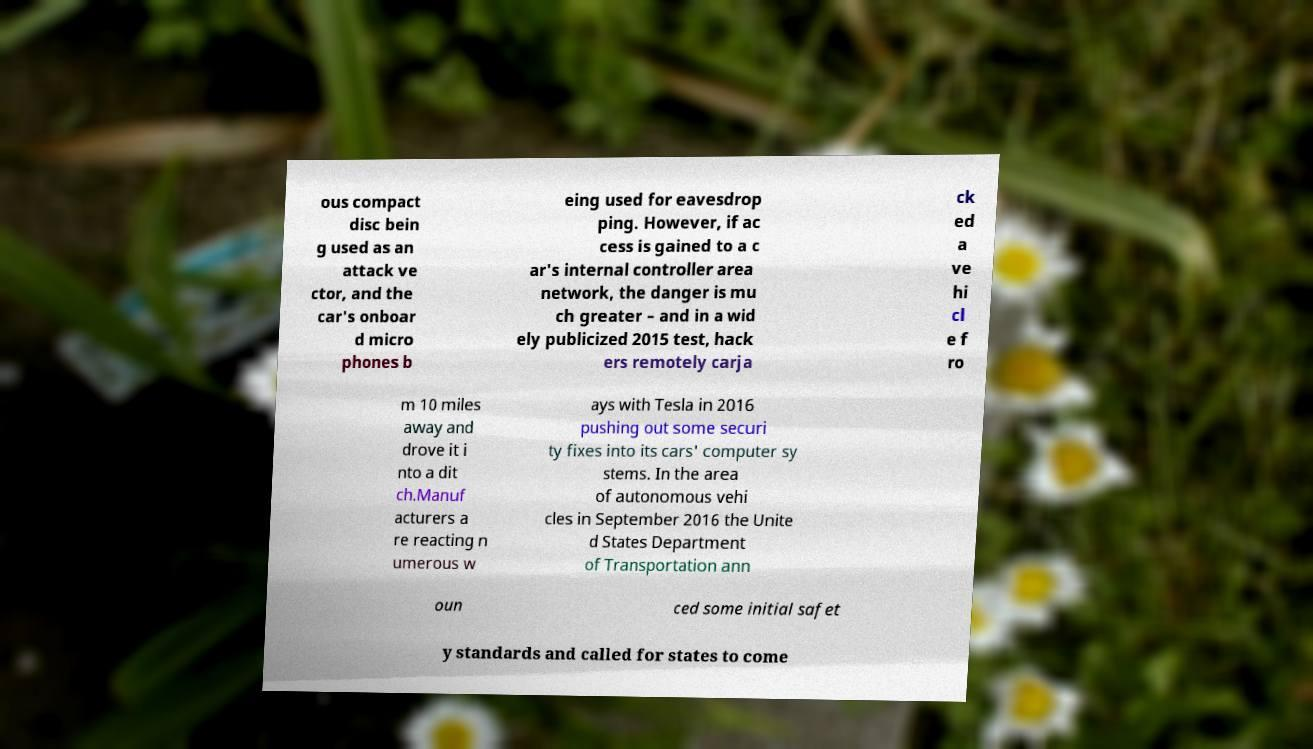For documentation purposes, I need the text within this image transcribed. Could you provide that? ous compact disc bein g used as an attack ve ctor, and the car's onboar d micro phones b eing used for eavesdrop ping. However, if ac cess is gained to a c ar's internal controller area network, the danger is mu ch greater – and in a wid ely publicized 2015 test, hack ers remotely carja ck ed a ve hi cl e f ro m 10 miles away and drove it i nto a dit ch.Manuf acturers a re reacting n umerous w ays with Tesla in 2016 pushing out some securi ty fixes into its cars' computer sy stems. In the area of autonomous vehi cles in September 2016 the Unite d States Department of Transportation ann oun ced some initial safet y standards and called for states to come 